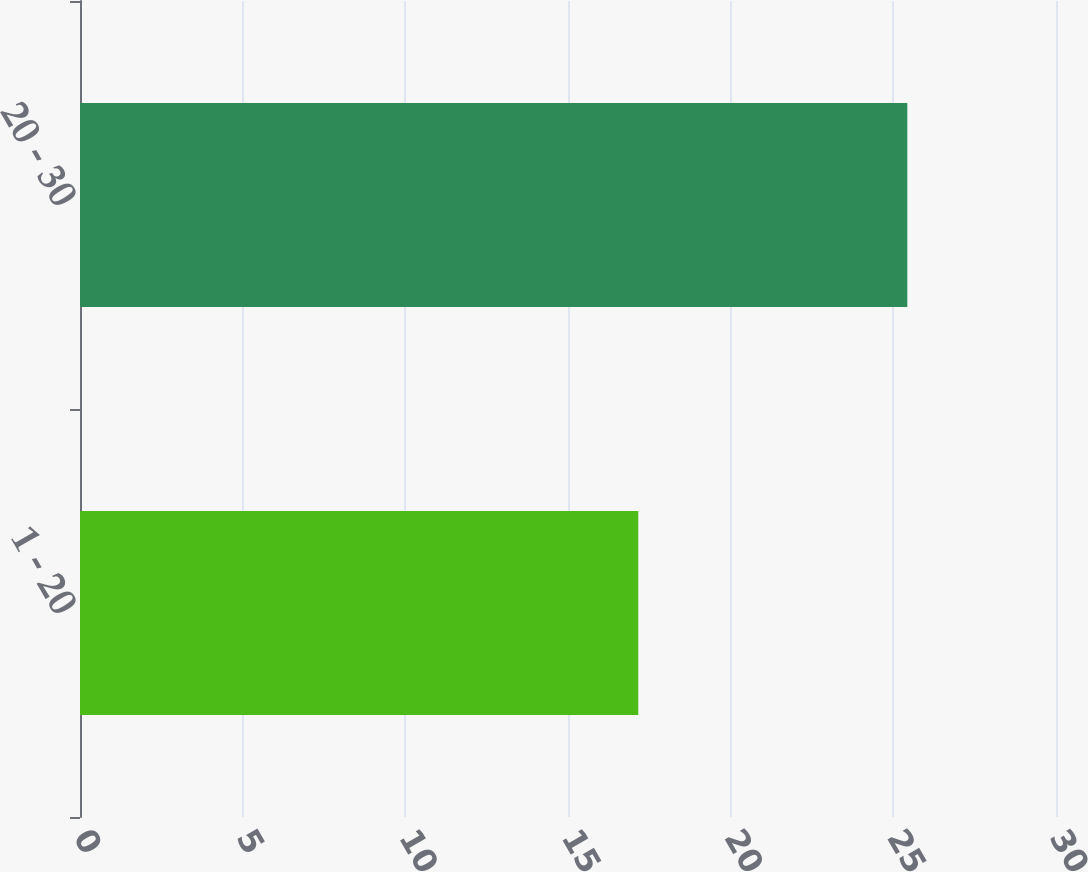Convert chart. <chart><loc_0><loc_0><loc_500><loc_500><bar_chart><fcel>1 - 20<fcel>20 - 30<nl><fcel>17.16<fcel>25.43<nl></chart> 